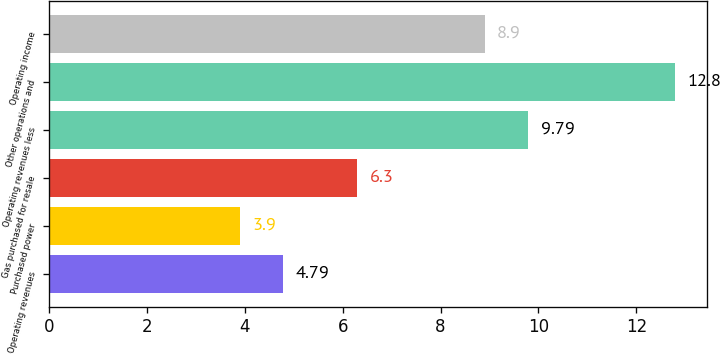Convert chart to OTSL. <chart><loc_0><loc_0><loc_500><loc_500><bar_chart><fcel>Operating revenues<fcel>Purchased power<fcel>Gas purchased for resale<fcel>Operating revenues less<fcel>Other operations and<fcel>Operating income<nl><fcel>4.79<fcel>3.9<fcel>6.3<fcel>9.79<fcel>12.8<fcel>8.9<nl></chart> 